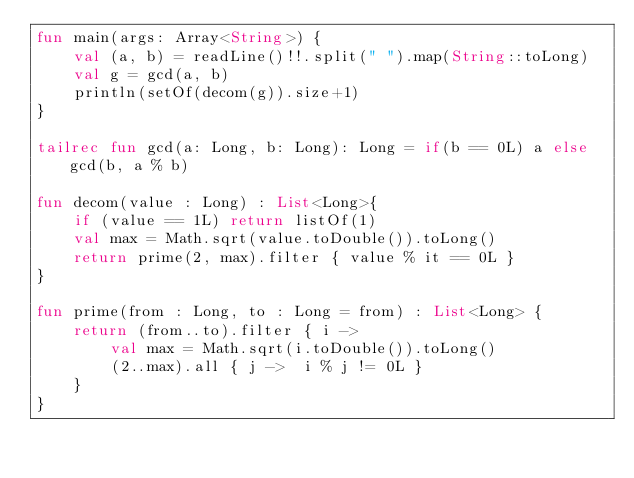Convert code to text. <code><loc_0><loc_0><loc_500><loc_500><_Kotlin_>fun main(args: Array<String>) {
    val (a, b) = readLine()!!.split(" ").map(String::toLong)
    val g = gcd(a, b)
    println(setOf(decom(g)).size+1)
}

tailrec fun gcd(a: Long, b: Long): Long = if(b == 0L) a else gcd(b, a % b)

fun decom(value : Long) : List<Long>{
    if (value == 1L) return listOf(1)
    val max = Math.sqrt(value.toDouble()).toLong()
    return prime(2, max).filter { value % it == 0L }
}

fun prime(from : Long, to : Long = from) : List<Long> {
    return (from..to).filter { i ->
        val max = Math.sqrt(i.toDouble()).toLong()
        (2..max).all { j ->  i % j != 0L }
    }
}</code> 